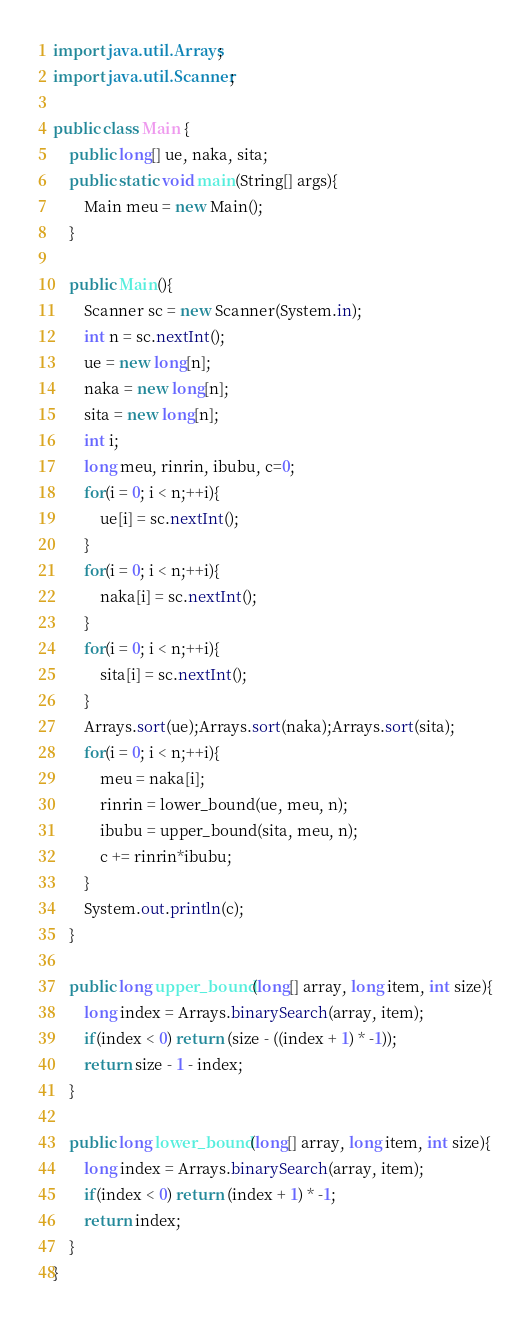Convert code to text. <code><loc_0><loc_0><loc_500><loc_500><_Java_>import java.util.Arrays;
import java.util.Scanner;

public class Main {
	public long[] ue, naka, sita;
	public static void main(String[] args){
		Main meu = new Main();
	}
	
	public Main(){
		Scanner sc = new Scanner(System.in);
		int n = sc.nextInt();
		ue = new long[n];
		naka = new long[n];
		sita = new long[n];
		int i;
		long meu, rinrin, ibubu, c=0;
		for(i = 0; i < n;++i){
			ue[i] = sc.nextInt();
		}
		for(i = 0; i < n;++i){
			naka[i] = sc.nextInt();
		}
		for(i = 0; i < n;++i){
			sita[i] = sc.nextInt();
		}
		Arrays.sort(ue);Arrays.sort(naka);Arrays.sort(sita);
		for(i = 0; i < n;++i){
			meu = naka[i];
			rinrin = lower_bound(ue, meu, n);
			ibubu = upper_bound(sita, meu, n);
			c += rinrin*ibubu;
		}
		System.out.println(c);
	}
	
	public long upper_bound(long[] array, long item, int size){
		long index = Arrays.binarySearch(array, item);
		if(index < 0) return (size - ((index + 1) * -1));
		return size - 1 - index;
	}
	
	public long lower_bound(long[] array, long item, int size){
		long index = Arrays.binarySearch(array, item);
		if(index < 0) return (index + 1) * -1;
		return index;
	}
}
</code> 